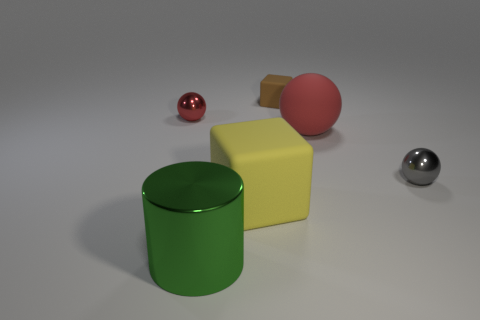Is there anything else that has the same shape as the large green metallic thing?
Ensure brevity in your answer.  No. What is the material of the red sphere that is the same size as the yellow rubber cube?
Your answer should be very brief. Rubber. How many other things are there of the same material as the tiny red ball?
Your response must be concise. 2. There is a matte object on the right side of the small cube; does it have the same shape as the metal object that is in front of the small gray object?
Provide a succinct answer. No. The metallic thing behind the metallic sphere to the right of the rubber block behind the small gray metallic sphere is what color?
Keep it short and to the point. Red. What number of other things are there of the same color as the tiny cube?
Your answer should be compact. 0. Are there fewer tiny red rubber cylinders than small metal things?
Offer a very short reply. Yes. What color is the metallic object that is left of the red rubber thing and in front of the large red matte thing?
Ensure brevity in your answer.  Green. There is a big red object that is the same shape as the gray thing; what is its material?
Ensure brevity in your answer.  Rubber. Is the number of metal objects greater than the number of small brown rubber objects?
Your response must be concise. Yes. 